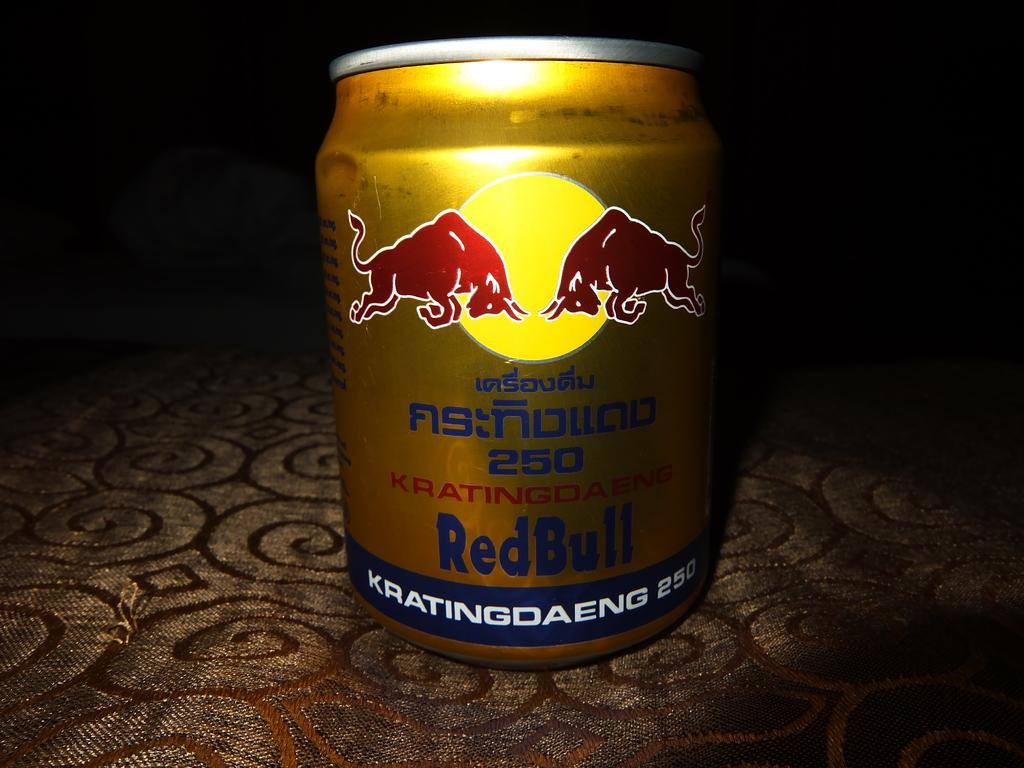<image>
Relay a brief, clear account of the picture shown. A gold can of Red Bull that has two bulls on it. 